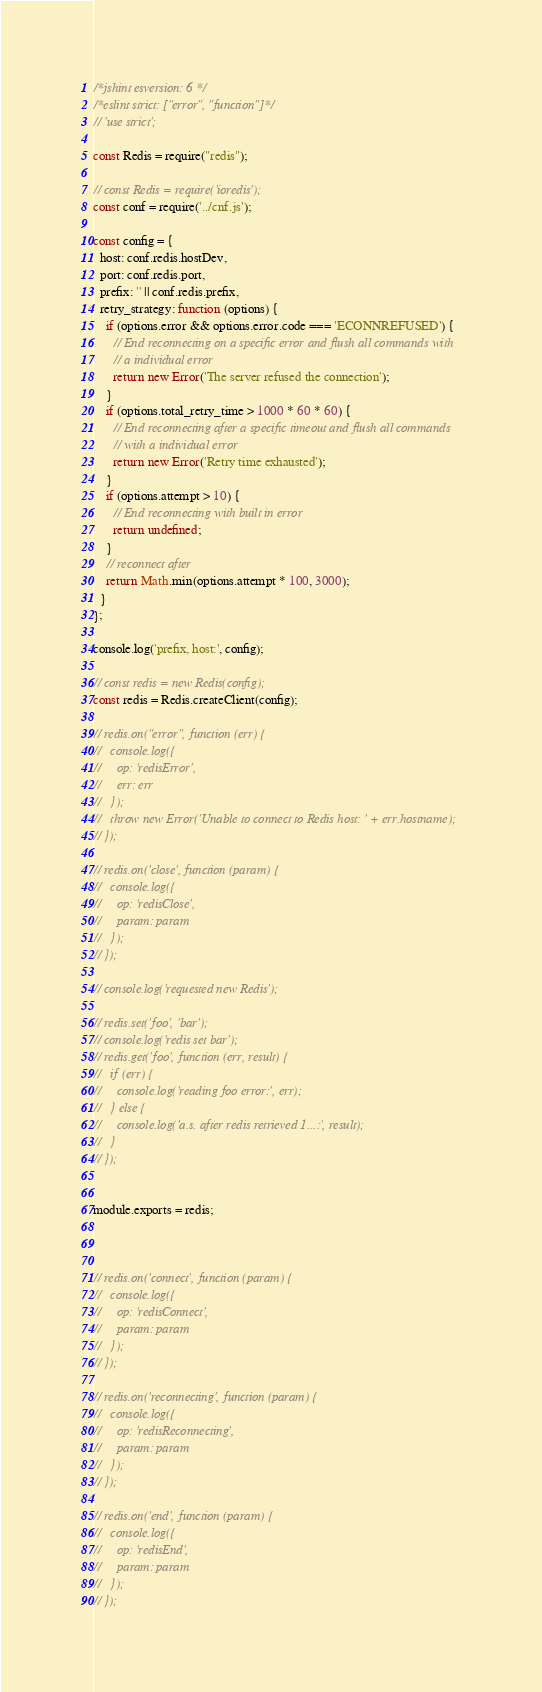Convert code to text. <code><loc_0><loc_0><loc_500><loc_500><_JavaScript_>/*jshint esversion: 6 */
/*eslint strict: ["error", "function"]*/
// 'use strict';

const Redis = require("redis");

// const Redis = require('ioredis');
const conf = require('../cnf.js');

const config = {
  host: conf.redis.hostDev,
  port: conf.redis.port,
  prefix: '' || conf.redis.prefix,
  retry_strategy: function (options) {
    if (options.error && options.error.code === 'ECONNREFUSED') {
      // End reconnecting on a specific error and flush all commands with
      // a individual error
      return new Error('The server refused the connection');
    }
    if (options.total_retry_time > 1000 * 60 * 60) {
      // End reconnecting after a specific timeout and flush all commands
      // with a individual error
      return new Error('Retry time exhausted');
    }
    if (options.attempt > 10) {
      // End reconnecting with built in error
      return undefined;
    }
    // reconnect after
    return Math.min(options.attempt * 100, 3000);
  }
};

console.log('prefix, host:', config);

// const redis = new Redis(config);
const redis = Redis.createClient(config);

// redis.on("error", function (err) {
//   console.log({
//     op: 'redisError',
//     err: err
//   });
//   throw new Error('Unable to connect to Redis host: ' + err.hostname);
// });

// redis.on('close', function (param) {
//   console.log({
//     op: 'redisClose',
//     param: param
//   });
// });

// console.log('requested new Redis');

// redis.set('foo', 'bar');
// console.log('redis set bar');
// redis.get('foo', function (err, result) {
//   if (err) {
//     console.log('reading foo error:', err);
//   } else {
//     console.log('a.s. after redis retrieved 1...:', result);
//   }
// });


module.exports = redis;



// redis.on('connect', function (param) {
//   console.log({
//     op: 'redisConnect',
//     param: param
//   });
// });

// redis.on('reconnecting', function (param) {
//   console.log({
//     op: 'redisReconnecting',
//     param: param
//   });
// });

// redis.on('end', function (param) {
//   console.log({
//     op: 'redisEnd',
//     param: param
//   });
// });</code> 